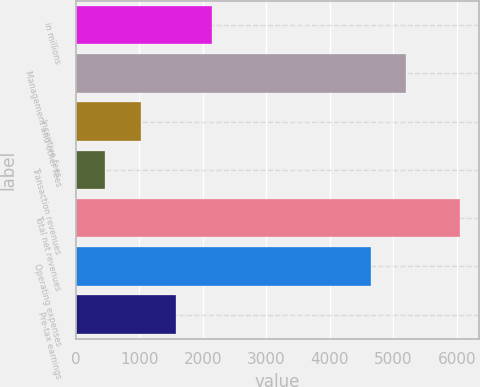<chart> <loc_0><loc_0><loc_500><loc_500><bar_chart><fcel>in millions<fcel>Management and other fees<fcel>Incentive fees<fcel>Transaction revenues<fcel>Total net revenues<fcel>Operating expenses<fcel>Pre-tax earnings<nl><fcel>2138.8<fcel>5204.6<fcel>1023.6<fcel>466<fcel>6042<fcel>4647<fcel>1581.2<nl></chart> 